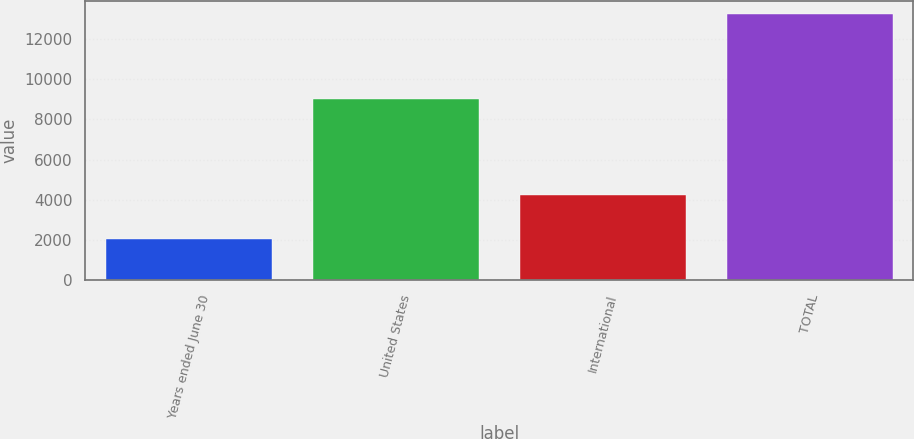Convert chart to OTSL. <chart><loc_0><loc_0><loc_500><loc_500><bar_chart><fcel>Years ended June 30<fcel>United States<fcel>International<fcel>TOTAL<nl><fcel>2017<fcel>9031<fcel>4226<fcel>13257<nl></chart> 